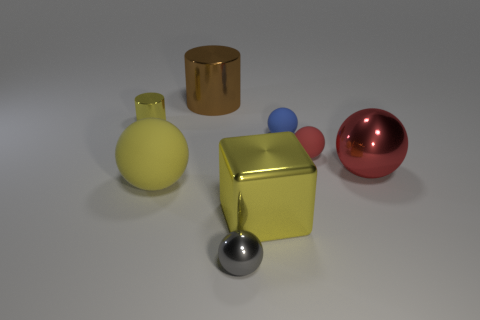Subtract all blue matte spheres. How many spheres are left? 4 Subtract all gray balls. How many balls are left? 4 Subtract all spheres. How many objects are left? 3 Add 1 metallic cylinders. How many objects exist? 9 Subtract 3 spheres. How many spheres are left? 2 Subtract all gray balls. How many red cylinders are left? 0 Subtract all gray things. Subtract all big yellow blocks. How many objects are left? 6 Add 4 blocks. How many blocks are left? 5 Add 3 tiny blue matte cylinders. How many tiny blue matte cylinders exist? 3 Subtract 0 blue cylinders. How many objects are left? 8 